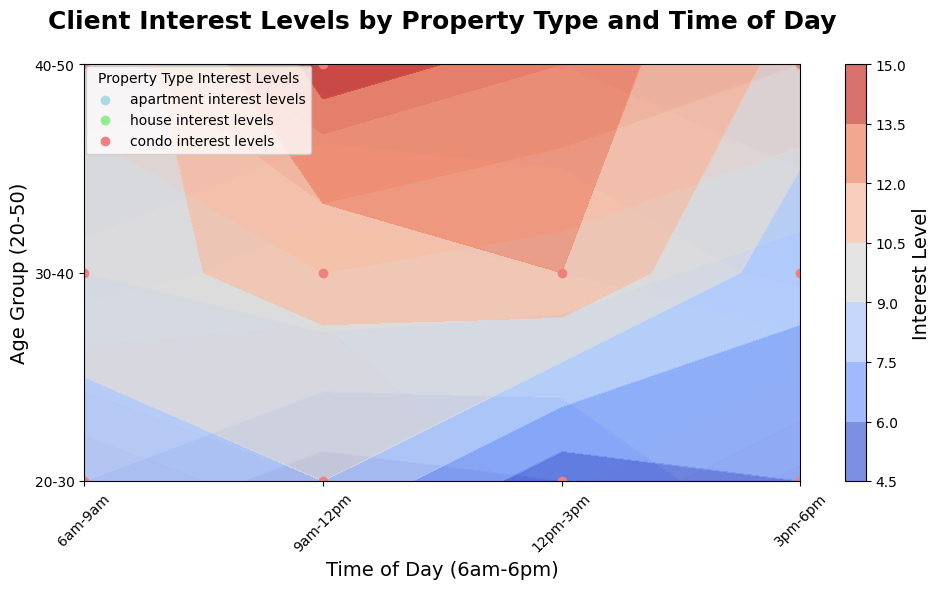What age group shows the highest interest in house properties from 3pm-6pm? To determine this, look at the contours for the time block 3pm-6pm and compare the interest levels for house properties across the different age groups. The highest contour will indicate the age group with the most interest. From the figure, the 40-50 age group has the highest interest level in house properties during this time block.
Answer: 40-50 Which property type has the highest overall interest level in the 9am-12pm time slot for the 40-50 age group? Focus on the time slot 9am-12pm for the 40-50 age group and compare the contours representing different property types. The house property shows the highest contour level indicating the highest interest.
Answer: House What's the difference in interest levels between apartments and condos for the 20-30 age group during 6am-9am? Compare the interest levels in the 6am-9am time slot for apartments and condos within the 20-30 age group. The interest level for apartments is 15 and for condos is 8. The difference is calculated as 15 - 8 = 7.
Answer: 7 Which age group is least interested in condos during 12pm-3pm? Assess the contours of the condos during the time slot 12pm-3pm across all age groups and determine the lowest interest level. The 20-30 age group shows the lowest contour, indicating their minimal interest.
Answer: 20-30 During which time slot does the interest level in apartments peak for the 30-40 age group? Observe the contours for the 30-40 age group and track the changes for apartments across the different time slots. The peak interest level for this age group in apartments is at 9am-12pm.
Answer: 9am-12pm What's the average interest level for house properties between 6am-9am for all age groups? Calculate the average interest level by summing the interest levels of house properties at 6am-9am for the age groups (20-30, 30-40, 40-50) and then divide by the number of age groups. The summed interest level is 10+12+15=37, and the average is 37/3 = 12.33.
Answer: 12.33 Compare the interest level in condos during 9am-12pm across the 20-30 and 40-50 age groups. Which age group shows a higher interest? Look at the contours for condos during the 9am-12pm slot for both age groups 20-30 and 40-50. Compare the interest levels shown: 9 for 20-30 and 14 for 40-50. The 40-50 age group shows a higher interest.
Answer: 40-50 What time of day has the lowest interest level for apartments across all age groups? Examine the contours for all age groups and identify the time slot where the interest level in apartments is lowest. Across all age groups, the lowest interest levels are from 12pm-3pm.
Answer: 12pm-3pm Which property type has the most consistent interest level throughout the day for the 30-40 age group? Assess the interest levels for each property type across all time slots for the 30-40 age group. The contours for condos are fairly consistent in this age group compared to apartments and houses, indicating the most consistent interest level.
Answer: Condo 